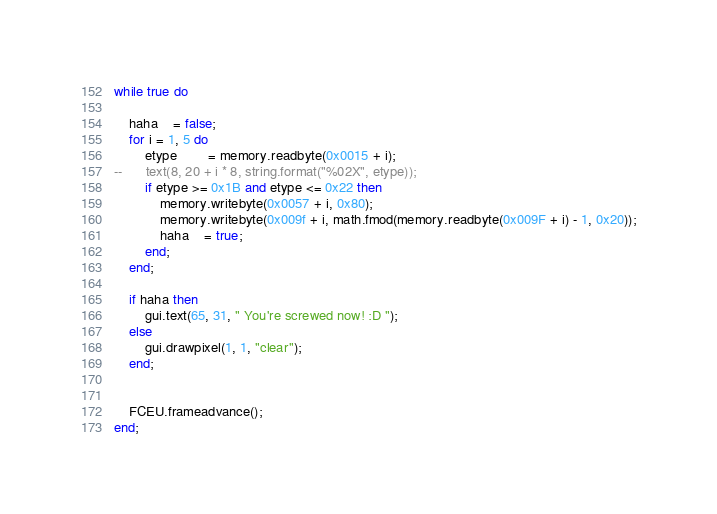<code> <loc_0><loc_0><loc_500><loc_500><_Lua_>while true do

	haha	= false;
	for i = 1, 5 do
		etype		= memory.readbyte(0x0015 + i);
--		text(8, 20 + i * 8, string.format("%02X", etype));
		if etype >= 0x1B and etype <= 0x22 then
			memory.writebyte(0x0057 + i, 0x80);
			memory.writebyte(0x009f + i, math.fmod(memory.readbyte(0x009F + i) - 1, 0x20));
			haha	= true;
		end;
	end;

	if haha then
		gui.text(65, 31, " You're screwed now! :D ");
	else
		gui.drawpixel(1, 1, "clear");
	end;


	FCEU.frameadvance();
end;</code> 